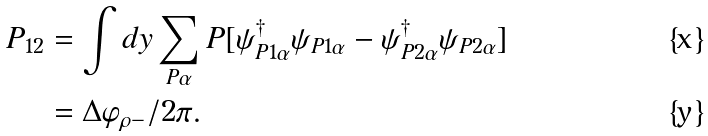Convert formula to latex. <formula><loc_0><loc_0><loc_500><loc_500>P _ { 1 2 } & = \int d y \sum _ { P \alpha } P [ \psi _ { P 1 \alpha } ^ { \dag } \psi _ { P 1 \alpha } - \psi _ { P 2 \alpha } ^ { \dag } \psi _ { P 2 \alpha } ] \\ & = \Delta \varphi _ { \rho - } / 2 \pi .</formula> 